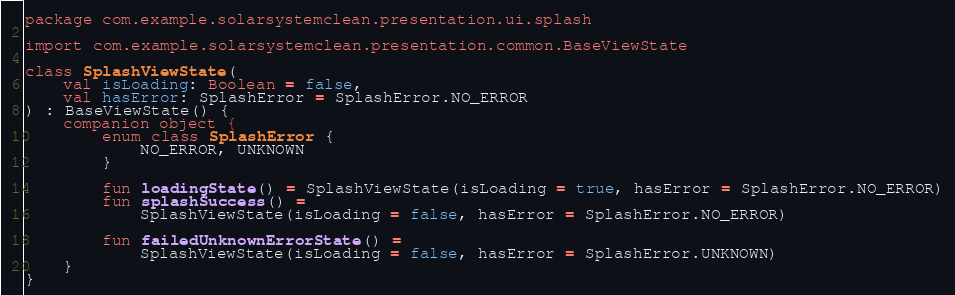Convert code to text. <code><loc_0><loc_0><loc_500><loc_500><_Kotlin_>package com.example.solarsystemclean.presentation.ui.splash

import com.example.solarsystemclean.presentation.common.BaseViewState

class SplashViewState(
    val isLoading: Boolean = false,
    val hasError: SplashError = SplashError.NO_ERROR
) : BaseViewState() {
    companion object {
        enum class SplashError {
            NO_ERROR, UNKNOWN
        }

        fun loadingState() = SplashViewState(isLoading = true, hasError = SplashError.NO_ERROR)
        fun splashSuccess() =
            SplashViewState(isLoading = false, hasError = SplashError.NO_ERROR)

        fun failedUnknownErrorState() =
            SplashViewState(isLoading = false, hasError = SplashError.UNKNOWN)
    }
}</code> 